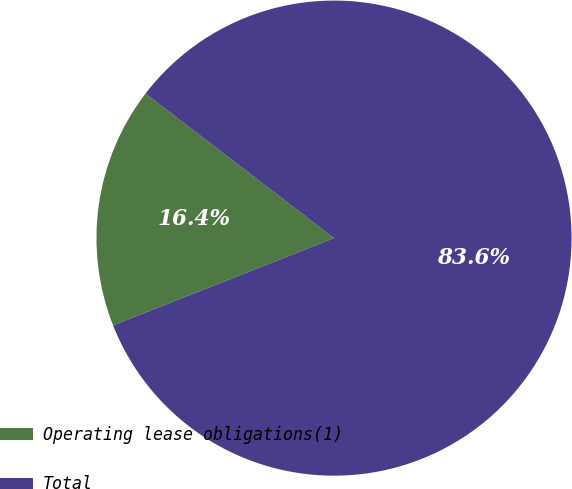Convert chart. <chart><loc_0><loc_0><loc_500><loc_500><pie_chart><fcel>Operating lease obligations(1)<fcel>Total<nl><fcel>16.4%<fcel>83.6%<nl></chart> 